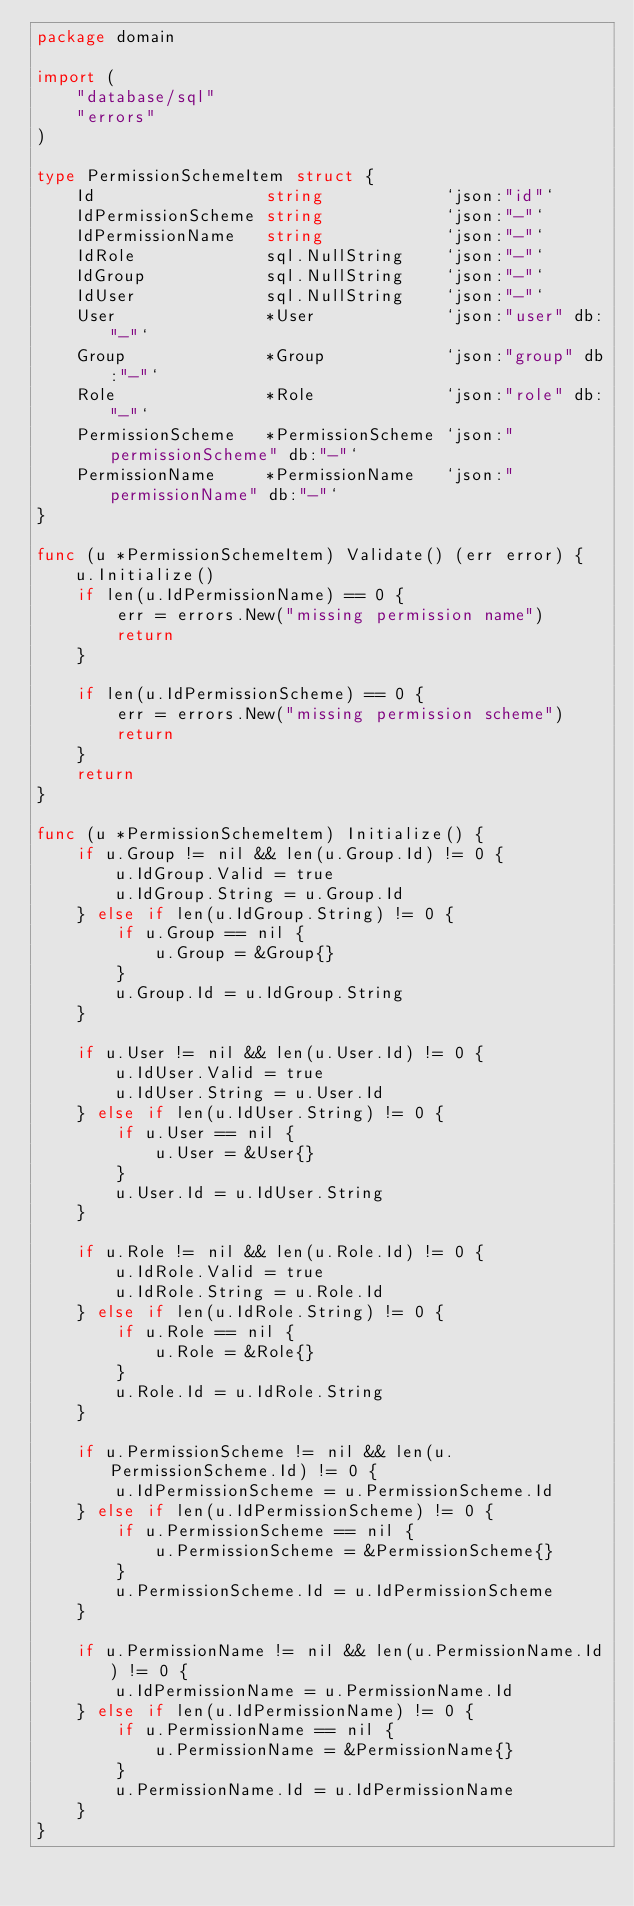Convert code to text. <code><loc_0><loc_0><loc_500><loc_500><_Go_>package domain

import (
	"database/sql"
	"errors"
)

type PermissionSchemeItem struct {
	Id                 string            `json:"id"`
	IdPermissionScheme string            `json:"-"`
	IdPermissionName   string            `json:"-"`
	IdRole             sql.NullString    `json:"-"`
	IdGroup            sql.NullString    `json:"-"`
	IdUser             sql.NullString    `json:"-"`
	User               *User             `json:"user" db:"-"`
	Group              *Group            `json:"group" db:"-"`
	Role               *Role             `json:"role" db:"-"`
	PermissionScheme   *PermissionScheme `json:"permissionScheme" db:"-"`
	PermissionName     *PermissionName   `json:"permissionName" db:"-"`
}

func (u *PermissionSchemeItem) Validate() (err error) {
	u.Initialize()
	if len(u.IdPermissionName) == 0 {
		err = errors.New("missing permission name")
		return
	}

	if len(u.IdPermissionScheme) == 0 {
		err = errors.New("missing permission scheme")
		return
	}
	return
}

func (u *PermissionSchemeItem) Initialize() {
	if u.Group != nil && len(u.Group.Id) != 0 {
		u.IdGroup.Valid = true
		u.IdGroup.String = u.Group.Id
	} else if len(u.IdGroup.String) != 0 {
		if u.Group == nil {
			u.Group = &Group{}
		}
		u.Group.Id = u.IdGroup.String
	}

	if u.User != nil && len(u.User.Id) != 0 {
		u.IdUser.Valid = true
		u.IdUser.String = u.User.Id
	} else if len(u.IdUser.String) != 0 {
		if u.User == nil {
			u.User = &User{}
		}
		u.User.Id = u.IdUser.String
	}

	if u.Role != nil && len(u.Role.Id) != 0 {
		u.IdRole.Valid = true
		u.IdRole.String = u.Role.Id
	} else if len(u.IdRole.String) != 0 {
		if u.Role == nil {
			u.Role = &Role{}
		}
		u.Role.Id = u.IdRole.String
	}

	if u.PermissionScheme != nil && len(u.PermissionScheme.Id) != 0 {
		u.IdPermissionScheme = u.PermissionScheme.Id
	} else if len(u.IdPermissionScheme) != 0 {
		if u.PermissionScheme == nil {
			u.PermissionScheme = &PermissionScheme{}
		}
		u.PermissionScheme.Id = u.IdPermissionScheme
	}

	if u.PermissionName != nil && len(u.PermissionName.Id) != 0 {
		u.IdPermissionName = u.PermissionName.Id
	} else if len(u.IdPermissionName) != 0 {
		if u.PermissionName == nil {
			u.PermissionName = &PermissionName{}
		}
		u.PermissionName.Id = u.IdPermissionName
	}
}
</code> 